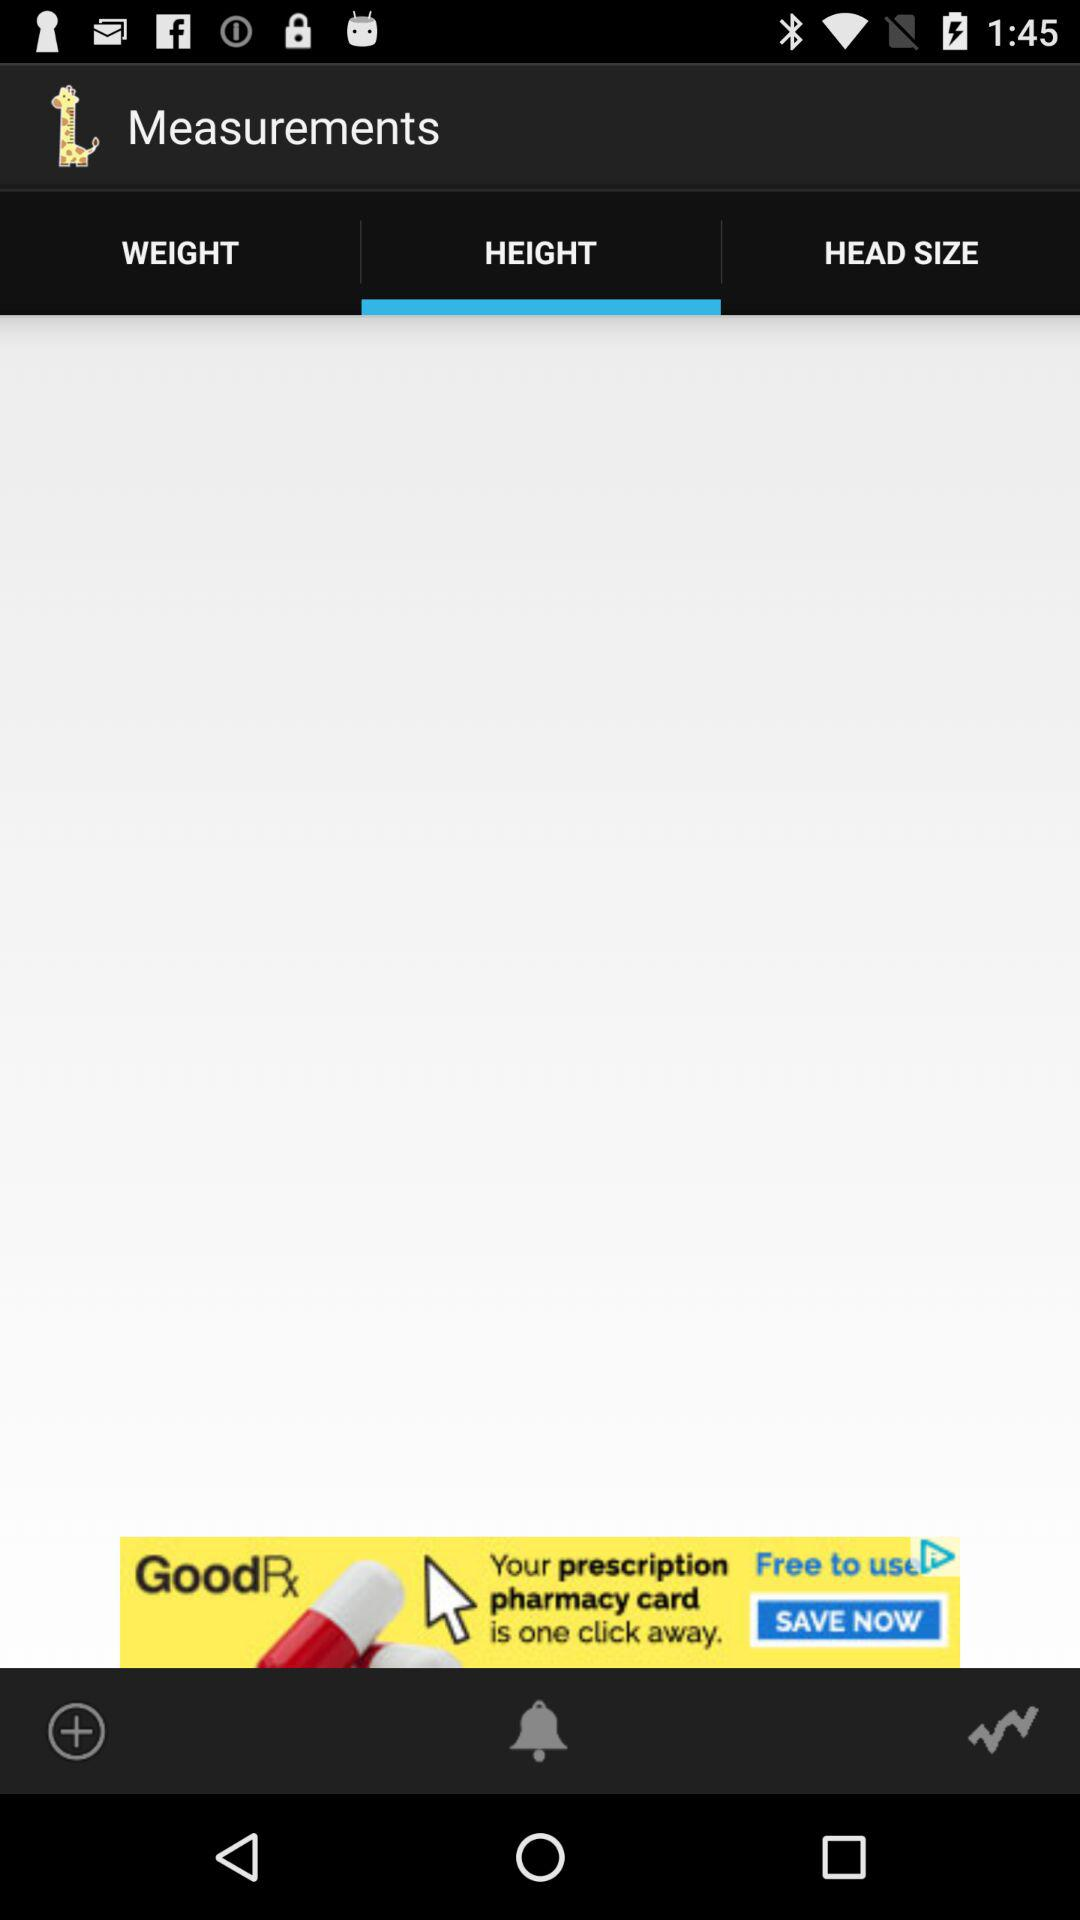What is the listed head size?
When the provided information is insufficient, respond with <no answer>. <no answer> 